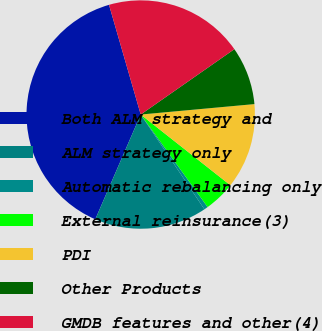Convert chart. <chart><loc_0><loc_0><loc_500><loc_500><pie_chart><fcel>Both ALM strategy and<fcel>ALM strategy only<fcel>Automatic rebalancing only<fcel>External reinsurance(3)<fcel>PDI<fcel>Other Products<fcel>GMDB features and other(4)<nl><fcel>39.01%<fcel>15.93%<fcel>0.55%<fcel>4.4%<fcel>12.09%<fcel>8.24%<fcel>19.78%<nl></chart> 